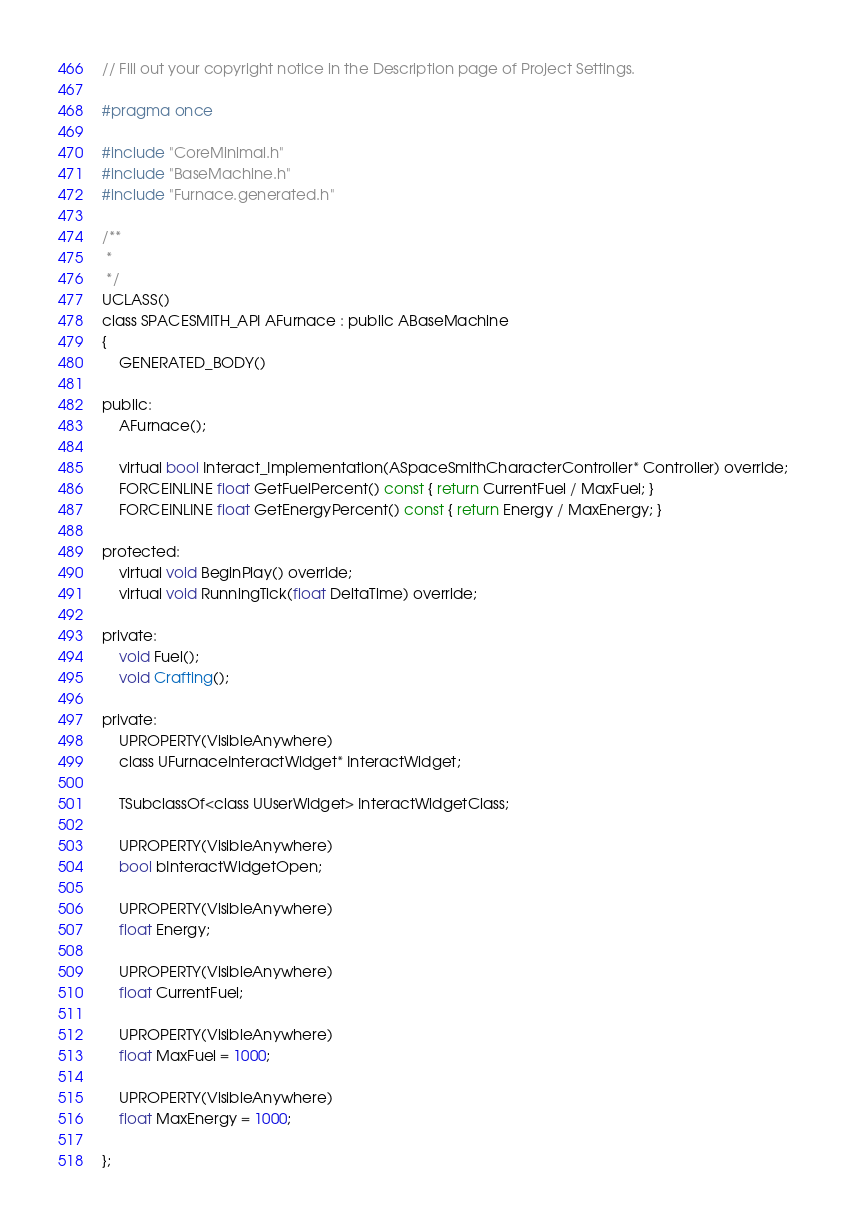Convert code to text. <code><loc_0><loc_0><loc_500><loc_500><_C_>// Fill out your copyright notice in the Description page of Project Settings.

#pragma once

#include "CoreMinimal.h"
#include "BaseMachine.h"
#include "Furnace.generated.h"

/**
 * 
 */
UCLASS()
class SPACESMITH_API AFurnace : public ABaseMachine
{
	GENERATED_BODY()
	
public:
	AFurnace();

	virtual bool Interact_Implementation(ASpaceSmithCharacterController* Controller) override;
	FORCEINLINE float GetFuelPercent() const { return CurrentFuel / MaxFuel; }
	FORCEINLINE float GetEnergyPercent() const { return Energy / MaxEnergy; }

protected:
	virtual void BeginPlay() override;
	virtual void RunningTick(float DeltaTime) override;

private:
	void Fuel();
	void Crafting();

private:
	UPROPERTY(VisibleAnywhere)
	class UFurnaceInteractWidget* InteractWidget;

	TSubclassOf<class UUserWidget> InteractWidgetClass;

	UPROPERTY(VisibleAnywhere)
	bool bInteractWidgetOpen;

	UPROPERTY(VisibleAnywhere)
	float Energy;

	UPROPERTY(VisibleAnywhere)
	float CurrentFuel;

	UPROPERTY(VisibleAnywhere)
	float MaxFuel = 1000;

	UPROPERTY(VisibleAnywhere)
	float MaxEnergy = 1000;

};
</code> 